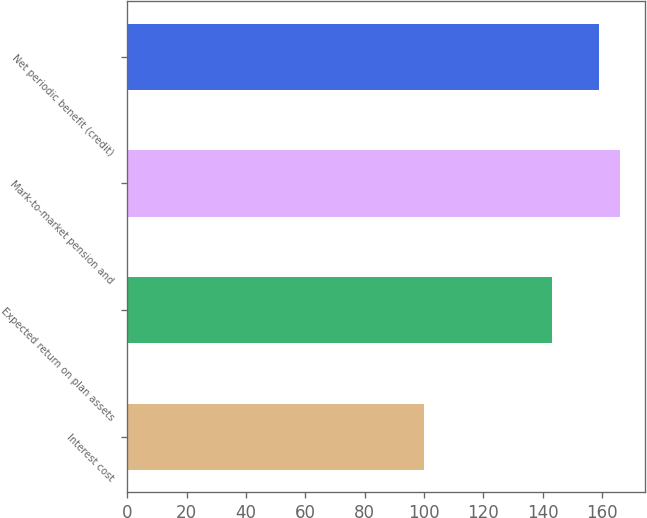Convert chart. <chart><loc_0><loc_0><loc_500><loc_500><bar_chart><fcel>Interest cost<fcel>Expected return on plan assets<fcel>Mark-to-market pension and<fcel>Net periodic benefit (credit)<nl><fcel>100<fcel>143<fcel>166<fcel>159<nl></chart> 